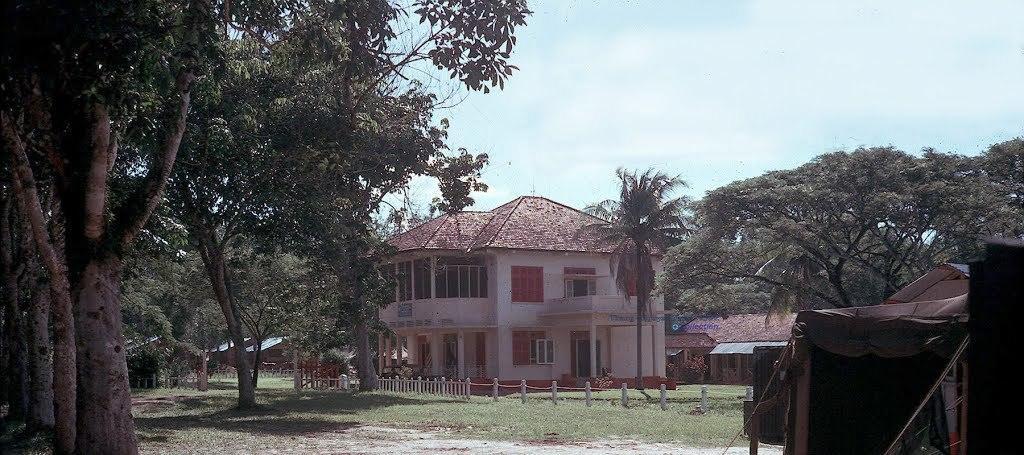Can you describe this image briefly? In this picture we can see a few houses. There is some fencing on the path. We can see tents on the rights. Some grass is visible on the ground. We can see trees on the right and left side of the image. Sky is blue in color and cloudy. 